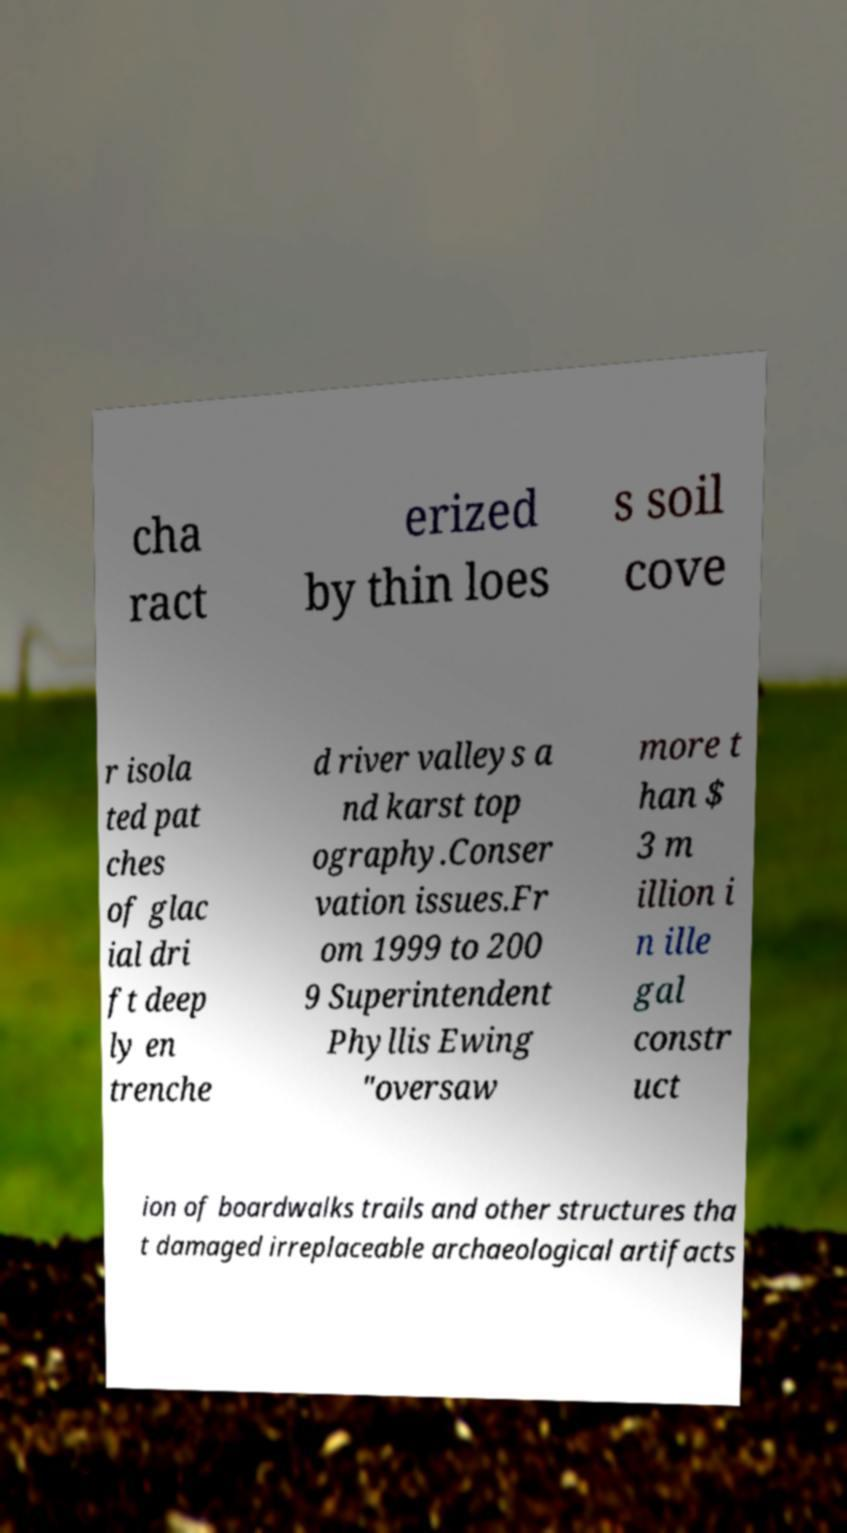Can you accurately transcribe the text from the provided image for me? cha ract erized by thin loes s soil cove r isola ted pat ches of glac ial dri ft deep ly en trenche d river valleys a nd karst top ography.Conser vation issues.Fr om 1999 to 200 9 Superintendent Phyllis Ewing "oversaw more t han $ 3 m illion i n ille gal constr uct ion of boardwalks trails and other structures tha t damaged irreplaceable archaeological artifacts 